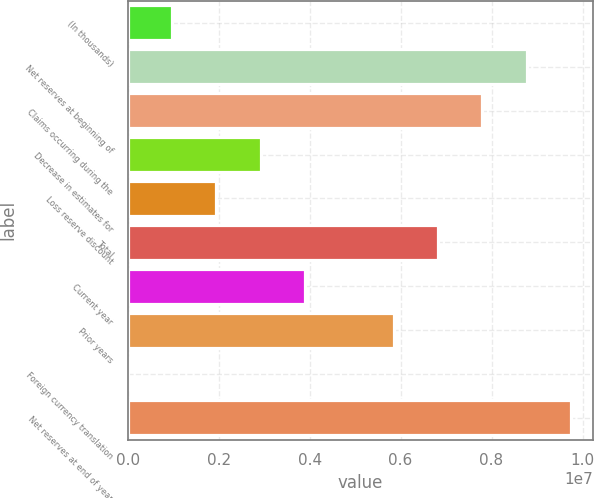Convert chart. <chart><loc_0><loc_0><loc_500><loc_500><bar_chart><fcel>(In thousands)<fcel>Net reserves at beginning of<fcel>Claims occurring during the<fcel>Decrease in estimates for<fcel>Loss reserve discount<fcel>Total<fcel>Current year<fcel>Prior years<fcel>Foreign currency translation<fcel>Net reserves at end of year<nl><fcel>975284<fcel>8.776e+06<fcel>7.80091e+06<fcel>2.92546e+06<fcel>1.95037e+06<fcel>6.82582e+06<fcel>3.90055e+06<fcel>5.85073e+06<fcel>195<fcel>9.75109e+06<nl></chart> 